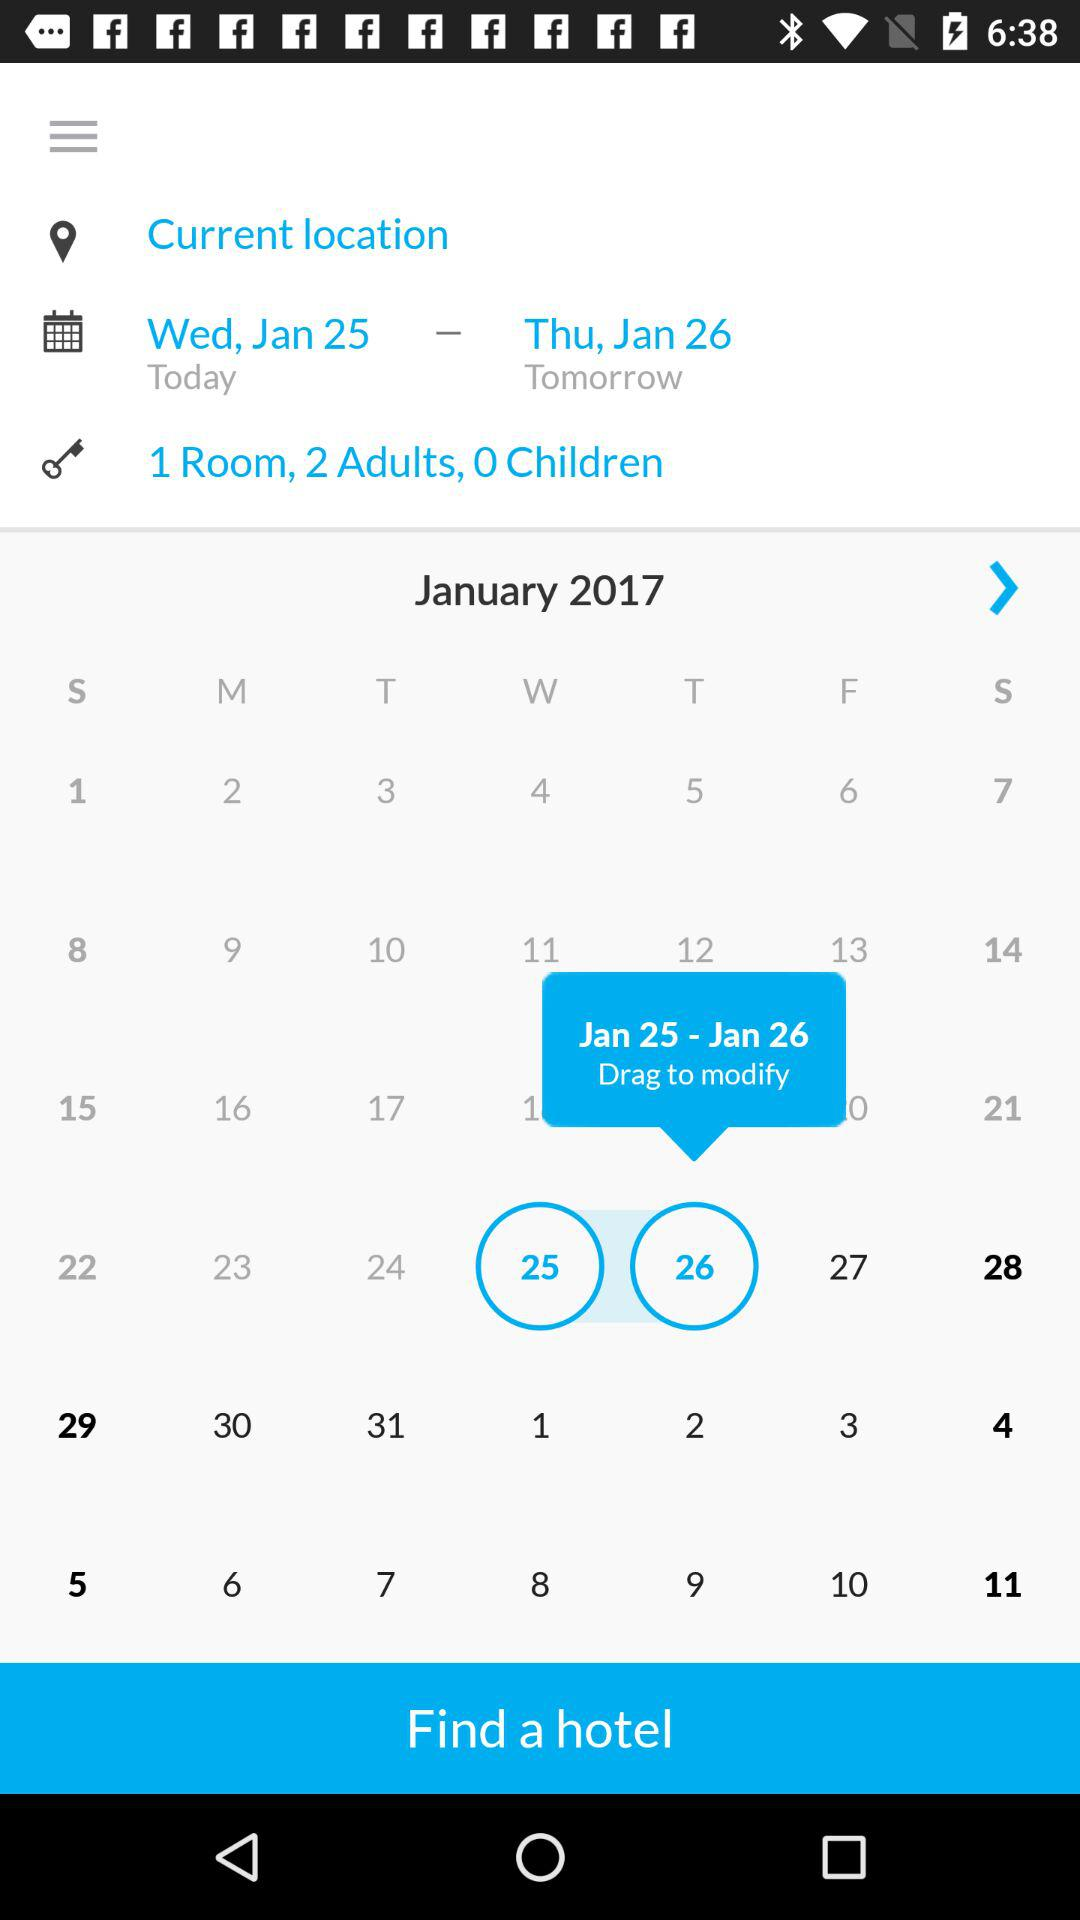How many days are selected?
Answer the question using a single word or phrase. 2 